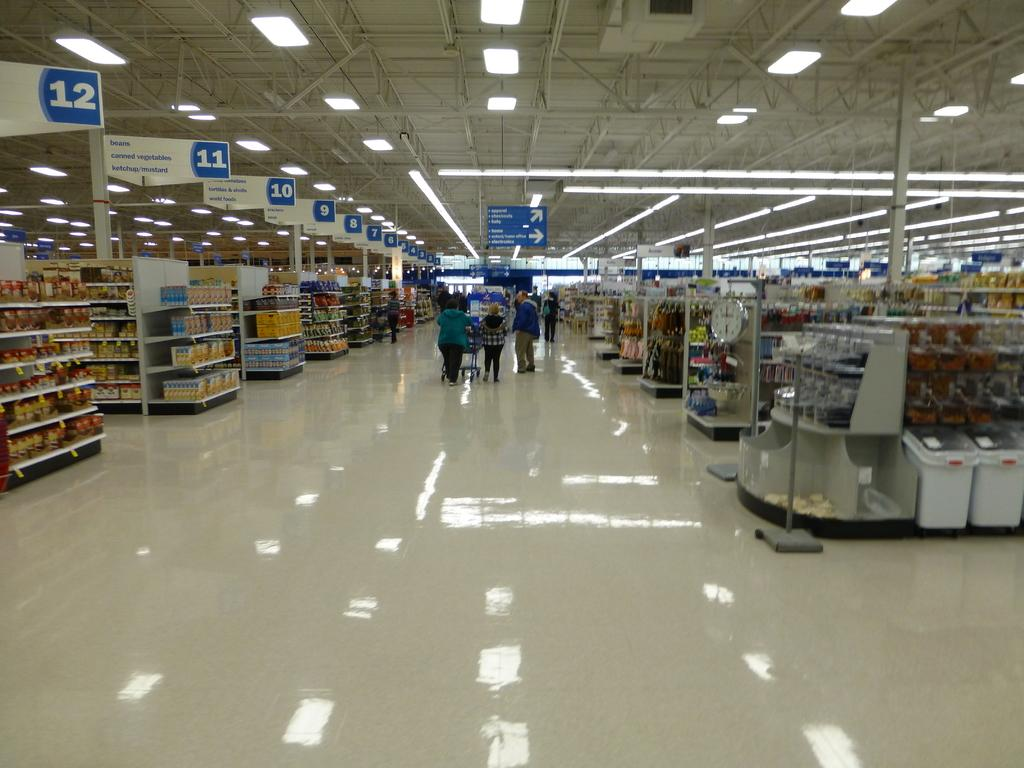Provide a one-sentence caption for the provided image. a walmart with the aisles numbered in order up to 12. 